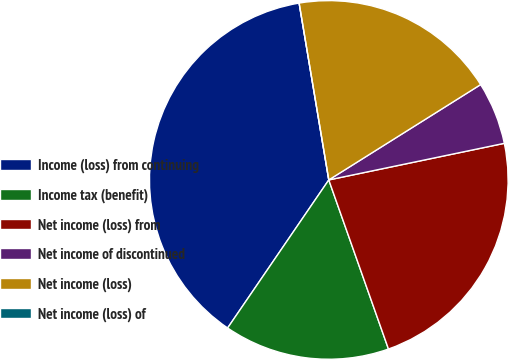Convert chart. <chart><loc_0><loc_0><loc_500><loc_500><pie_chart><fcel>Income (loss) from continuing<fcel>Income tax (benefit)<fcel>Net income (loss) from<fcel>Net income of discontinued<fcel>Net income (loss)<fcel>Net income (loss) of<nl><fcel>37.81%<fcel>14.94%<fcel>22.87%<fcel>5.65%<fcel>18.72%<fcel>0.0%<nl></chart> 